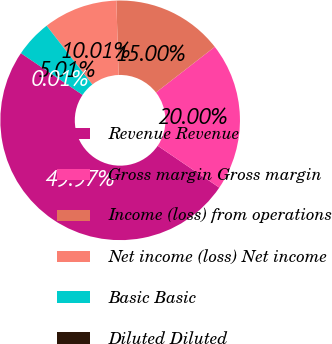Convert chart. <chart><loc_0><loc_0><loc_500><loc_500><pie_chart><fcel>Revenue Revenue<fcel>Gross margin Gross margin<fcel>Income (loss) from operations<fcel>Net income (loss) Net income<fcel>Basic Basic<fcel>Diluted Diluted<nl><fcel>49.97%<fcel>20.0%<fcel>15.0%<fcel>10.01%<fcel>5.01%<fcel>0.01%<nl></chart> 